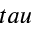Convert formula to latex. <formula><loc_0><loc_0><loc_500><loc_500>t a u</formula> 